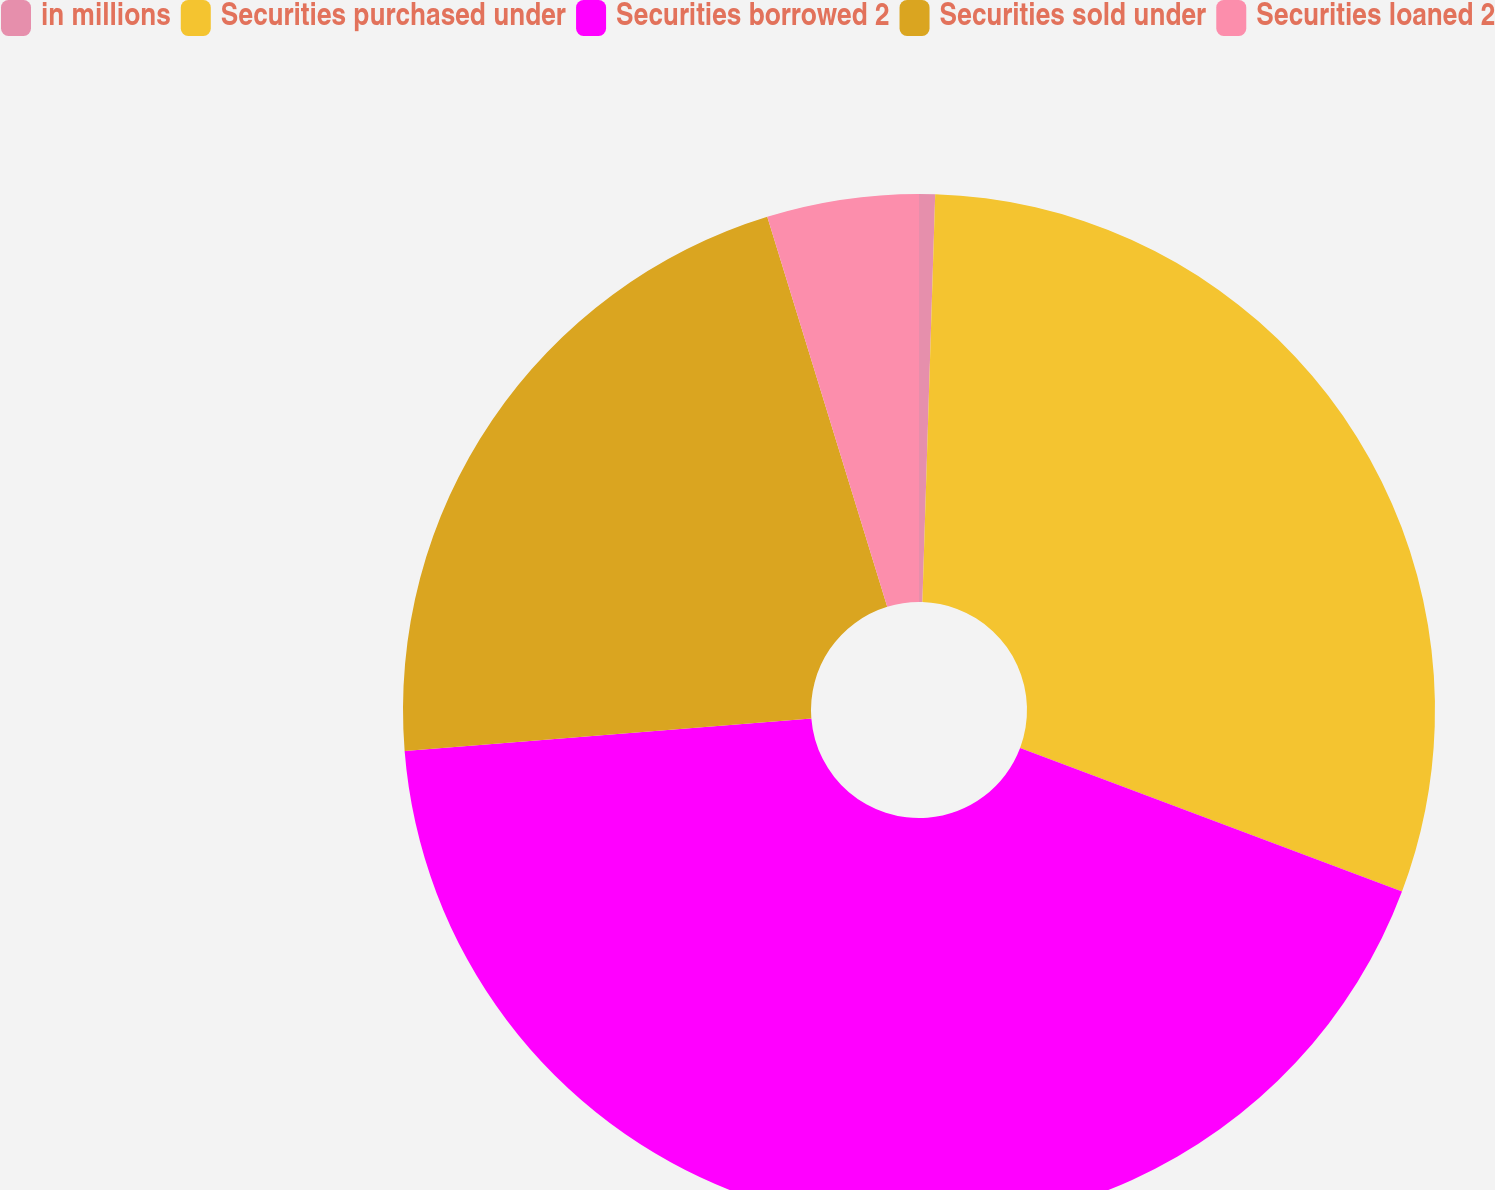<chart> <loc_0><loc_0><loc_500><loc_500><pie_chart><fcel>in millions<fcel>Securities purchased under<fcel>Securities borrowed 2<fcel>Securities sold under<fcel>Securities loaned 2<nl><fcel>0.5%<fcel>30.22%<fcel>43.01%<fcel>21.51%<fcel>4.75%<nl></chart> 